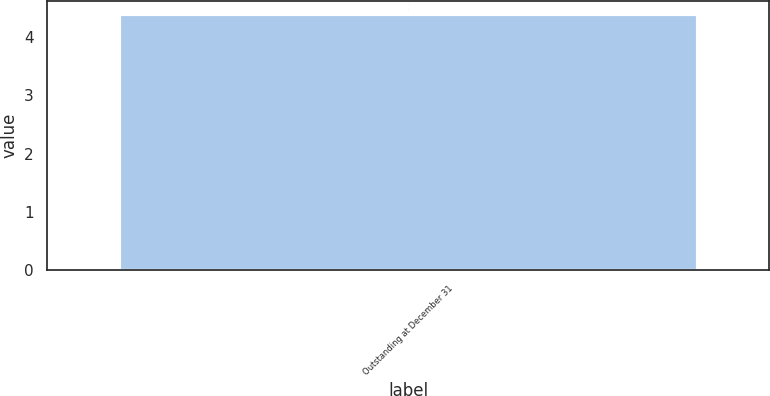Convert chart to OTSL. <chart><loc_0><loc_0><loc_500><loc_500><bar_chart><fcel>Outstanding at December 31<nl><fcel>4.4<nl></chart> 